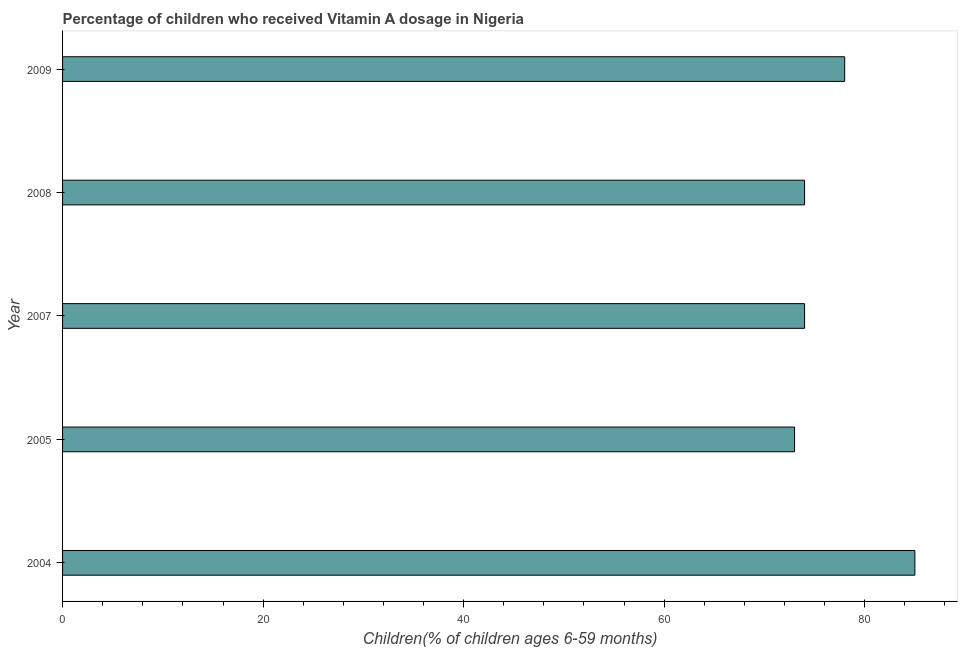What is the title of the graph?
Give a very brief answer. Percentage of children who received Vitamin A dosage in Nigeria. What is the label or title of the X-axis?
Make the answer very short. Children(% of children ages 6-59 months). What is the vitamin a supplementation coverage rate in 2009?
Make the answer very short. 78. Across all years, what is the maximum vitamin a supplementation coverage rate?
Keep it short and to the point. 85. In which year was the vitamin a supplementation coverage rate maximum?
Give a very brief answer. 2004. In which year was the vitamin a supplementation coverage rate minimum?
Ensure brevity in your answer.  2005. What is the sum of the vitamin a supplementation coverage rate?
Offer a very short reply. 384. What is the average vitamin a supplementation coverage rate per year?
Ensure brevity in your answer.  76.8. In how many years, is the vitamin a supplementation coverage rate greater than 68 %?
Your answer should be very brief. 5. Do a majority of the years between 2008 and 2007 (inclusive) have vitamin a supplementation coverage rate greater than 4 %?
Keep it short and to the point. No. What is the ratio of the vitamin a supplementation coverage rate in 2004 to that in 2009?
Give a very brief answer. 1.09. Is the vitamin a supplementation coverage rate in 2004 less than that in 2005?
Your answer should be very brief. No. What is the difference between the highest and the lowest vitamin a supplementation coverage rate?
Your answer should be compact. 12. In how many years, is the vitamin a supplementation coverage rate greater than the average vitamin a supplementation coverage rate taken over all years?
Provide a succinct answer. 2. How many bars are there?
Keep it short and to the point. 5. What is the Children(% of children ages 6-59 months) in 2004?
Your response must be concise. 85. What is the Children(% of children ages 6-59 months) of 2005?
Make the answer very short. 73. What is the Children(% of children ages 6-59 months) in 2008?
Keep it short and to the point. 74. What is the difference between the Children(% of children ages 6-59 months) in 2004 and 2007?
Offer a very short reply. 11. What is the difference between the Children(% of children ages 6-59 months) in 2004 and 2009?
Provide a succinct answer. 7. What is the difference between the Children(% of children ages 6-59 months) in 2005 and 2008?
Your answer should be very brief. -1. What is the difference between the Children(% of children ages 6-59 months) in 2007 and 2008?
Provide a short and direct response. 0. What is the difference between the Children(% of children ages 6-59 months) in 2007 and 2009?
Ensure brevity in your answer.  -4. What is the ratio of the Children(% of children ages 6-59 months) in 2004 to that in 2005?
Your response must be concise. 1.16. What is the ratio of the Children(% of children ages 6-59 months) in 2004 to that in 2007?
Keep it short and to the point. 1.15. What is the ratio of the Children(% of children ages 6-59 months) in 2004 to that in 2008?
Your response must be concise. 1.15. What is the ratio of the Children(% of children ages 6-59 months) in 2004 to that in 2009?
Offer a terse response. 1.09. What is the ratio of the Children(% of children ages 6-59 months) in 2005 to that in 2009?
Provide a short and direct response. 0.94. What is the ratio of the Children(% of children ages 6-59 months) in 2007 to that in 2008?
Your response must be concise. 1. What is the ratio of the Children(% of children ages 6-59 months) in 2007 to that in 2009?
Offer a very short reply. 0.95. What is the ratio of the Children(% of children ages 6-59 months) in 2008 to that in 2009?
Your answer should be compact. 0.95. 